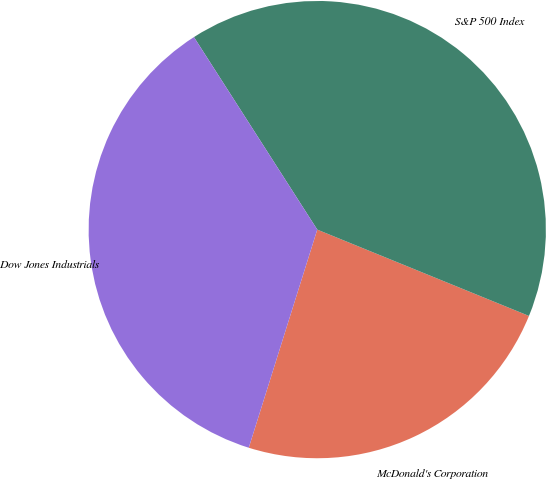Convert chart to OTSL. <chart><loc_0><loc_0><loc_500><loc_500><pie_chart><fcel>McDonald's Corporation<fcel>S&P 500 Index<fcel>Dow Jones Industrials<nl><fcel>23.68%<fcel>40.23%<fcel>36.09%<nl></chart> 